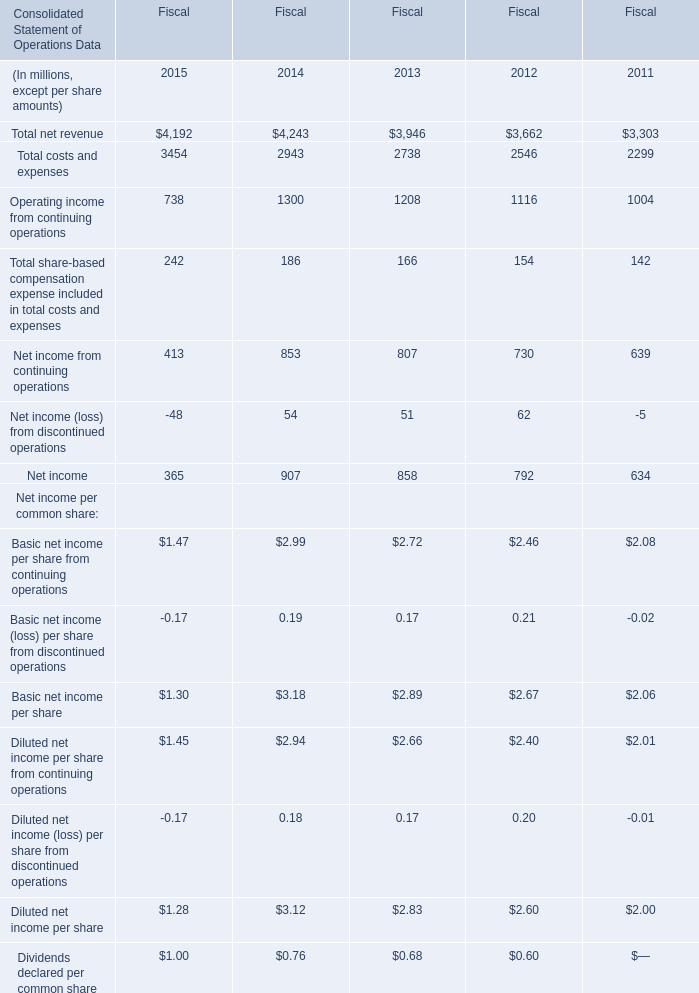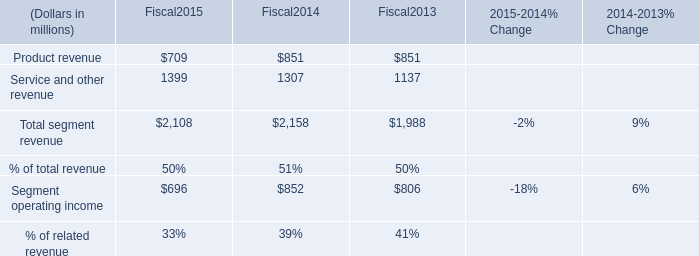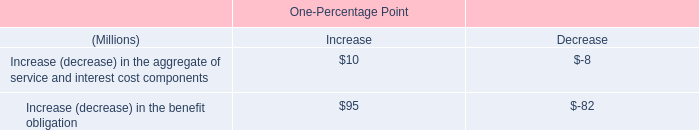without the change in market value of the investment portfolio in 2003 , what would the company 2019s obligations be under the deferred comp plan , in millions? 
Computations: (100 + 13)
Answer: 113.0. 